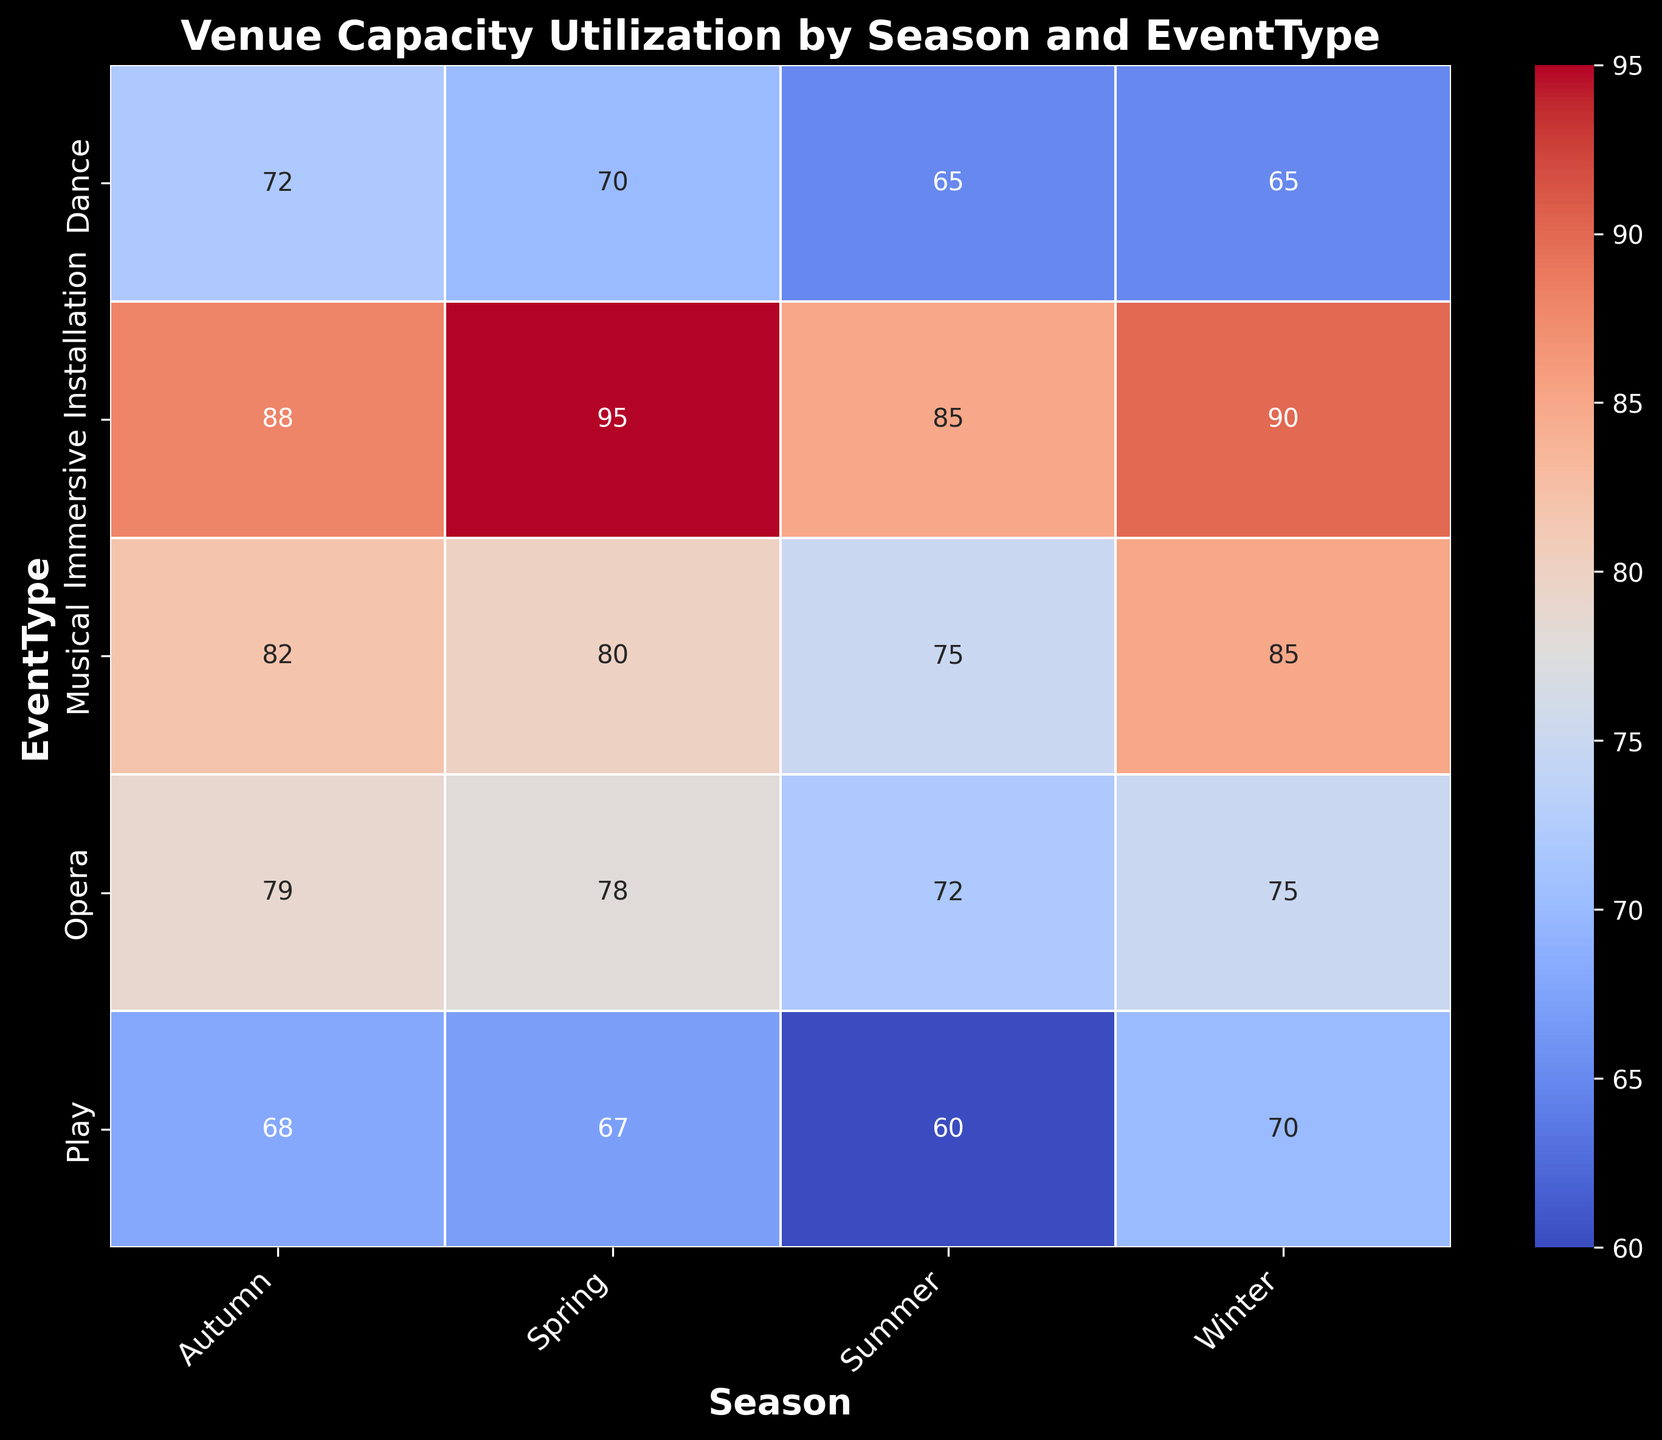Which event type has the highest capacity utilization across all seasons? Observe each event type and note the highest value for each season. "Immersive Installation" consistently has the highest utilization across all seasons: Winter (90), Spring (95), Summer (85), Autumn (88).
Answer: Immersive Installation Which season has the lowest capacity utilization for musicals? Look at the values for "Musical" across all seasons: Winter (85), Spring (80), Summer (75), Autumn (82). Summer has the lowest value for musicals at 75.
Answer: Summer What is the average capacity utilization for plays across all seasons? Add the percentages for plays across all seasons and divide by the number of seasons: (Winter 70 + Spring 67 + Summer 60 + Autumn 68) / 4 = 65.
Answer: 65% How does winter's capacity utilization for immersive installations compare to autumn's? Observe the percent utilization for "Immersive Installation" in Winter (90) and Autumn (88). Winter has a slightly higher utilization than Autumn.
Answer: Winter is higher Which season has the overall highest capacity utilization for operas? Observe each season for "Opera" values: Winter (75), Spring (78), Summer (72), Autumn (79). Autumn has the highest utilization at 79.
Answer: Autumn Which event type and season combination has the lowest capacity utilization? Look for the smallest value across the heatmap. The smallest value is "Dance" in Summer with 65.
Answer: Dance in Summer What is the difference in capacity utilization for dance events between winter and summer? Winter utilization for "Dance" is 65, and Summer utilization is also 65. The difference is 0.
Answer: 0 How does the capacity utilization for musicals in autumn compare to that in spring? Autumn capacity utilization for "Musical" is 82, and Spring is 80. Autumn is higher by 2 points.
Answer: Autumn is higher by 2 What is the total capacity utilization for all event types in spring? Add the values for all event types in Spring: 80 (Musical) + 67 (Play) + 95 (Immersive Installation) + 70 (Dance) + 78 (Opera) = 390.
Answer: 390 Which event type shows the greatest variability in capacity utilization across seasons? Compare the ranges (difference between max and min values) for each event type: Musical (85-75=10), Play (70-60=10), Immersive Installation (95-85=10), Dance (72-65=7), Opera (79-72=7). Many have the same range, but "Immersive Installation" peaks significantly in Spring (95).
Answer: Immersive Installation 